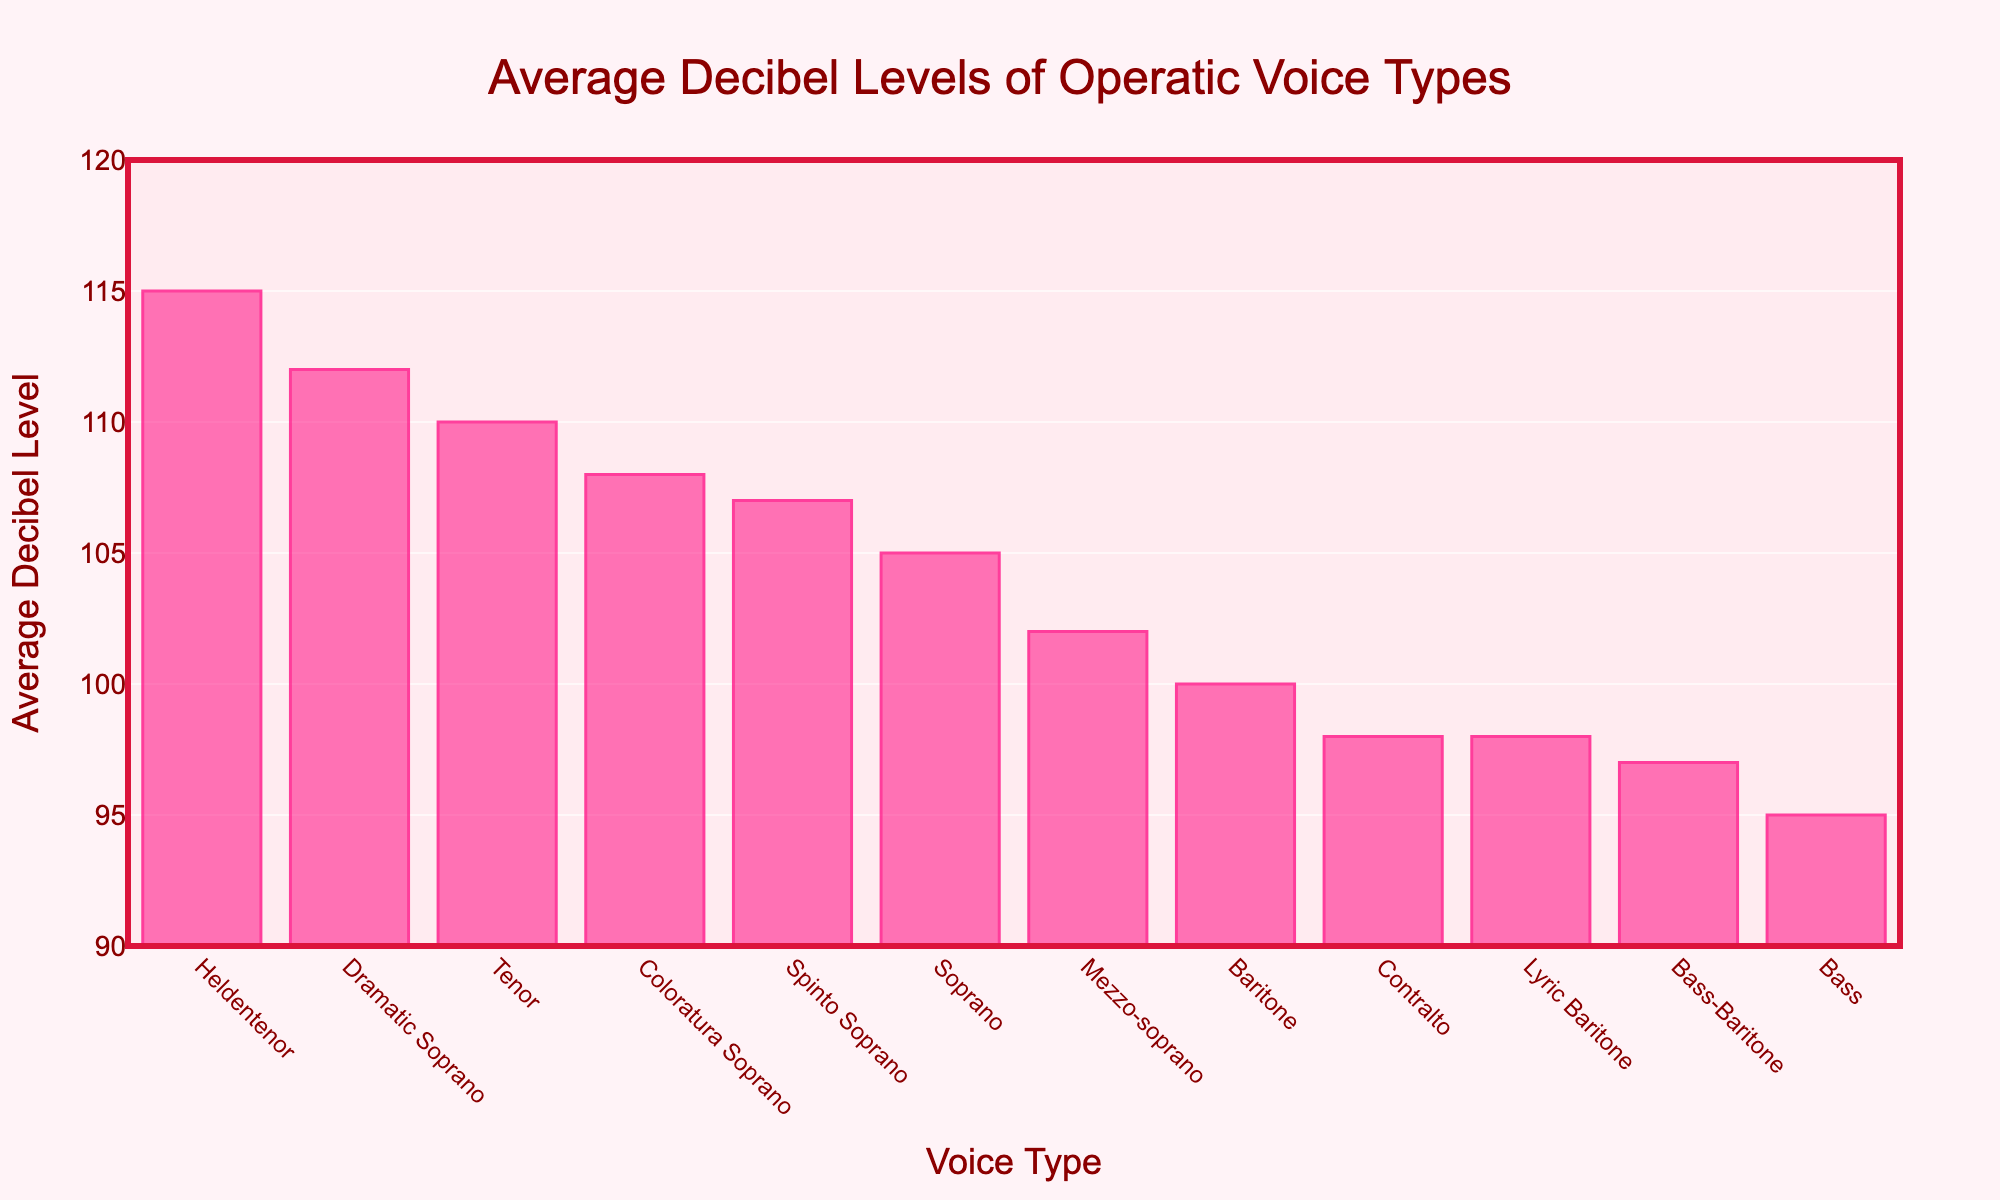Which voice type has the highest average decibel level? The bar corresponding to Heldentenor is the highest, which indicates it has the highest average decibel level.
Answer: Heldentenor Which voice type has the lowest average decibel level? The bar corresponding to Bass is the shortest, indicating it has the lowest average decibel level.
Answer: Bass How much higher is the average decibel level of a Dramatic Soprano compared to a Bass? Look at the height of the Dramatic Soprano's bar and the Bass's bar. Subtract the Bass's value (95) from the Dramatic Soprano's value (112).
Answer: 17 Which voice types have an average decibel level above 110? Identify bars with heights above the 110 mark on the y-axis: Heldentenor, Dramatic Soprano, Coloratura Soprano, and Tenor.
Answer: Heldentenor, Dramatic Soprano, Coloratura Soprano, Tenor What's the difference in average decibel level between a Soprano and a Baritone? Look at the heights of the Soprano's and Baritone's bars. Subtract the Baritone's value (100) from the Soprano's value (105).
Answer: 5 What is the average of the three lowest average decibel levels? Identify the three smallest bars (Bass, Bass-Baritone, and Contralto). Add their values (95 + 97 + 98) and divide by 3.
Answer: 96.67 Which voice type has an average decibel level closest to 100? Look for the bar whose height is closest to the 100 mark on the y-axis, which is the Baritone.
Answer: Baritone How many voice types have an average decibel level of 105 or more? Count the number of bars with heights reaching or above the 105 mark: Soprano, Tenor, Coloratura Soprano, Dramatic Soprano, Spinto Soprano, Heldentenor.
Answer: 6 What's the combined average decibel level of Mezzo-soprano and Lyric Baritone? Add the values for Mezzo-soprano and Lyric Baritone (102 + 98) and divide by 2.
Answer: 100 